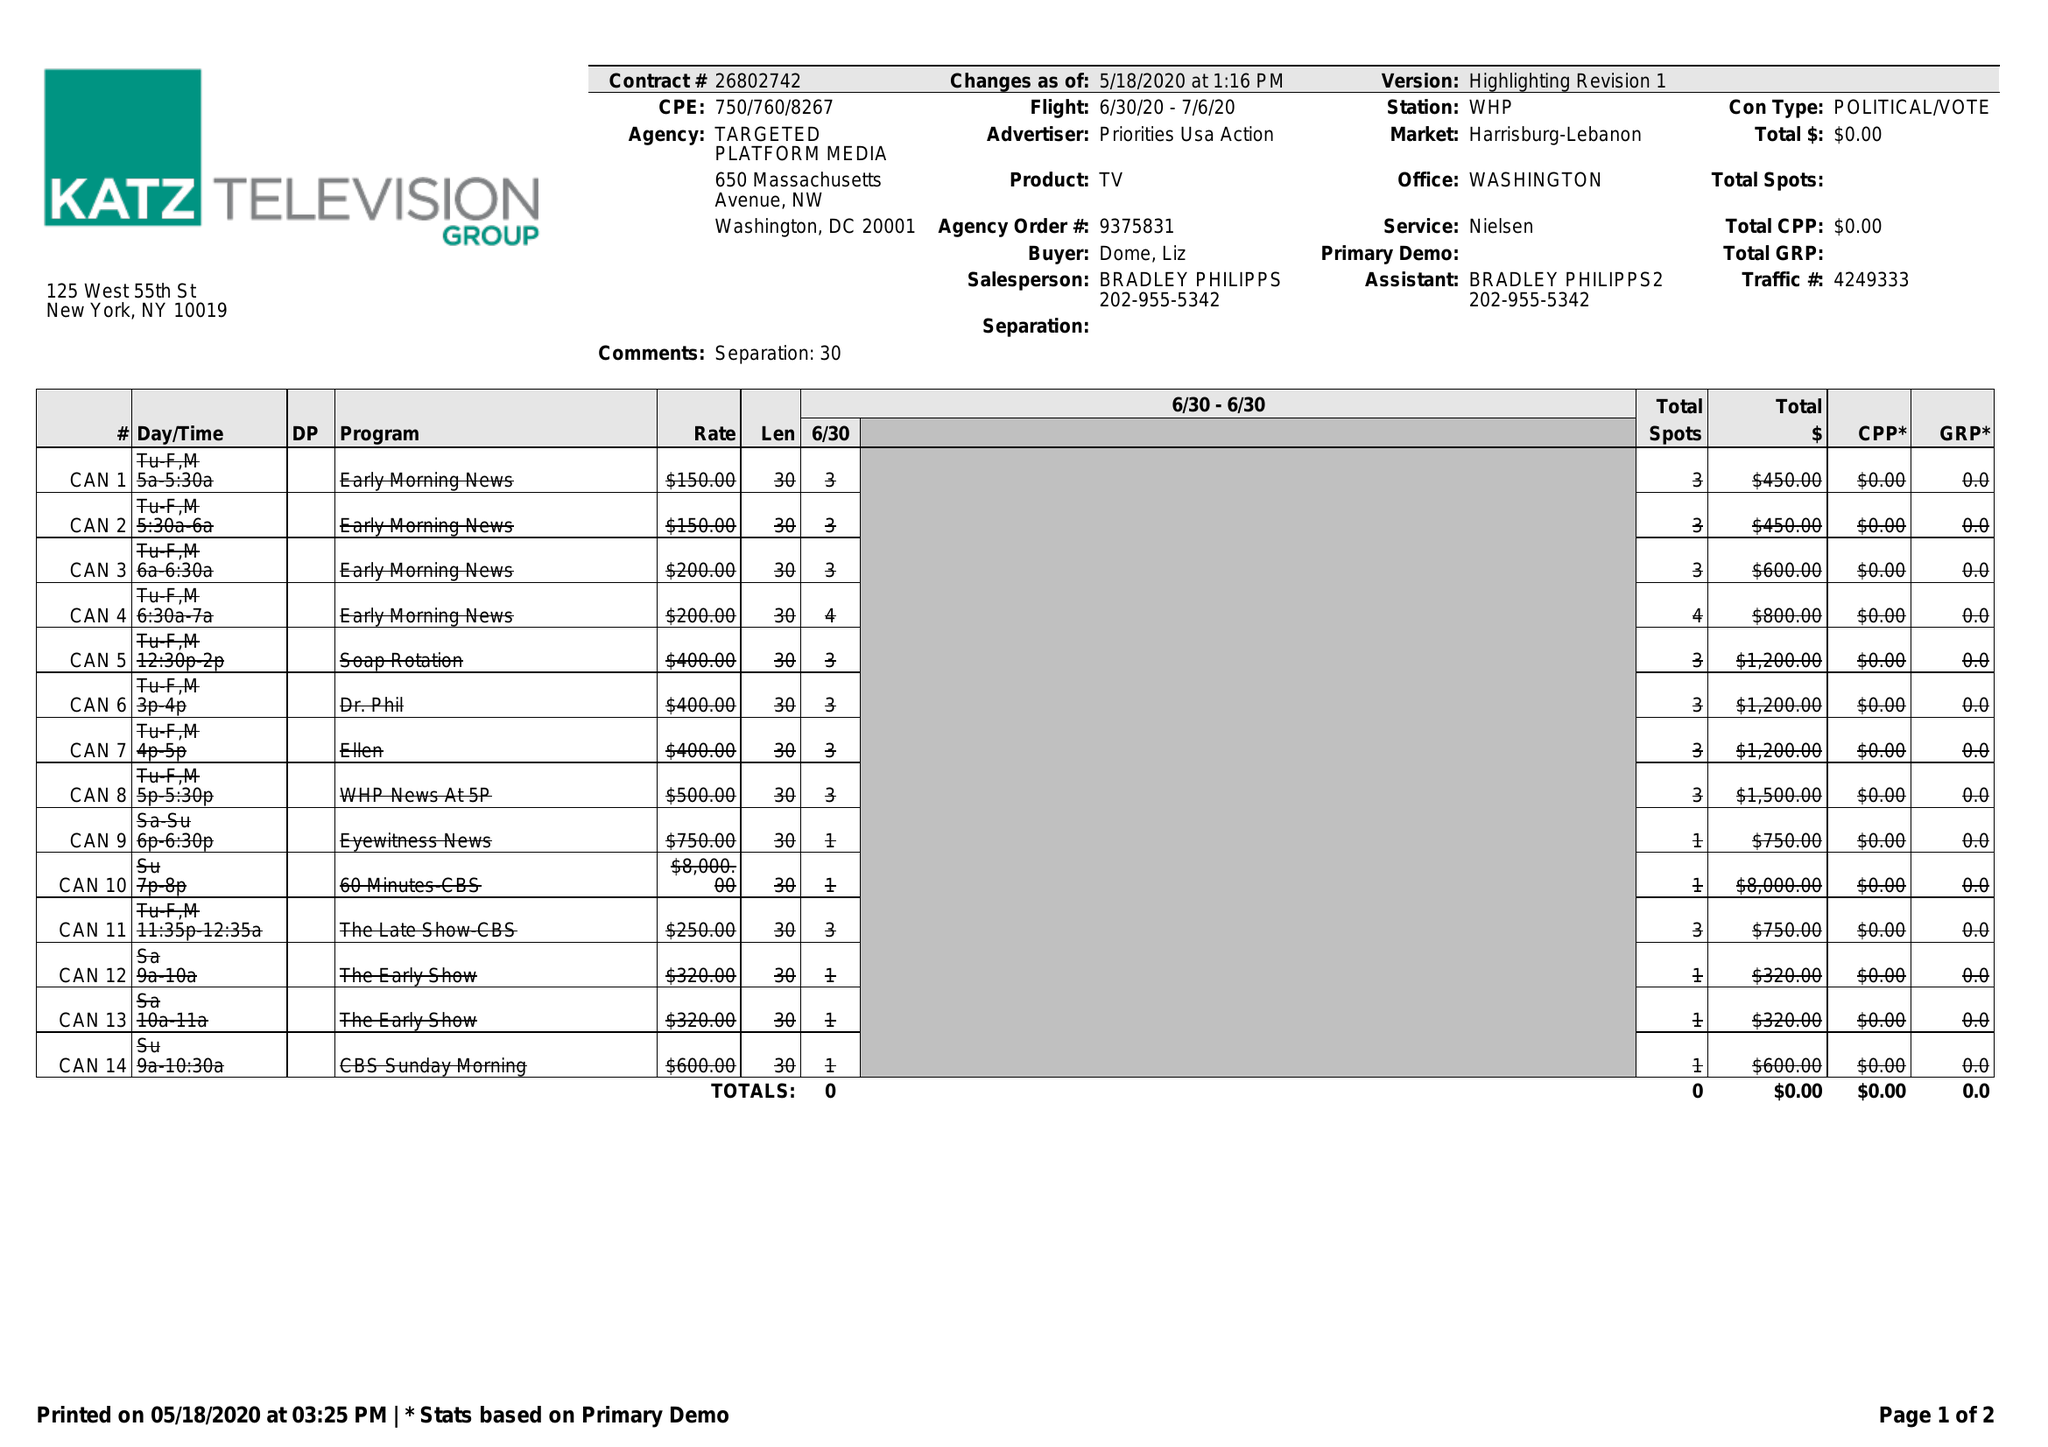What is the value for the advertiser?
Answer the question using a single word or phrase. PRIORITIES USA ACTION 